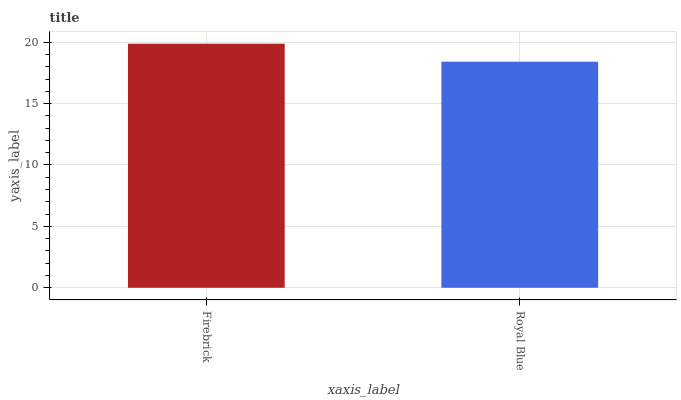Is Royal Blue the minimum?
Answer yes or no. Yes. Is Firebrick the maximum?
Answer yes or no. Yes. Is Royal Blue the maximum?
Answer yes or no. No. Is Firebrick greater than Royal Blue?
Answer yes or no. Yes. Is Royal Blue less than Firebrick?
Answer yes or no. Yes. Is Royal Blue greater than Firebrick?
Answer yes or no. No. Is Firebrick less than Royal Blue?
Answer yes or no. No. Is Firebrick the high median?
Answer yes or no. Yes. Is Royal Blue the low median?
Answer yes or no. Yes. Is Royal Blue the high median?
Answer yes or no. No. Is Firebrick the low median?
Answer yes or no. No. 